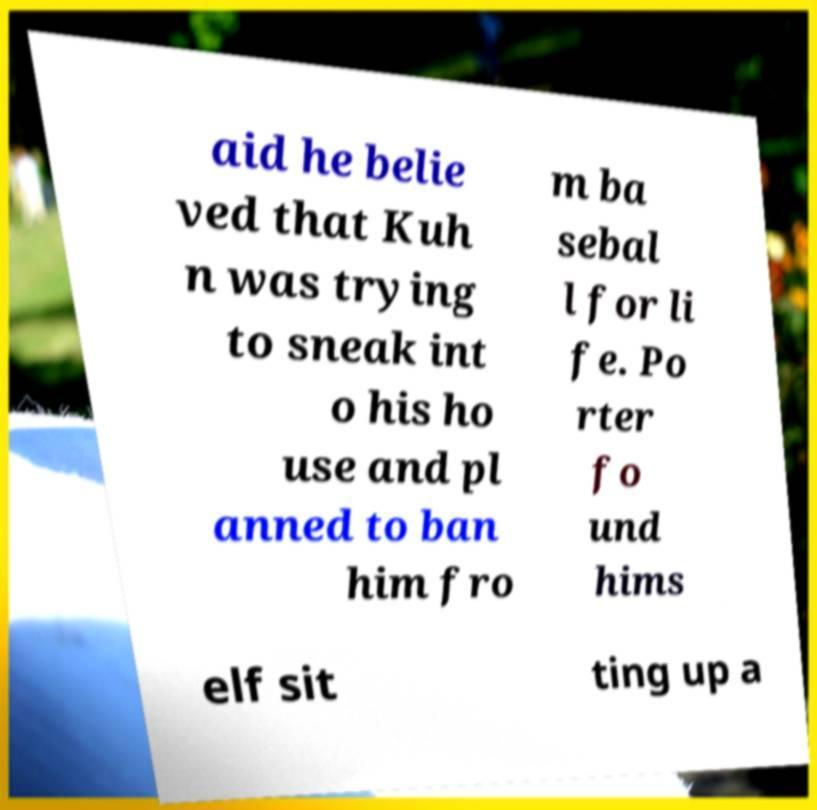There's text embedded in this image that I need extracted. Can you transcribe it verbatim? aid he belie ved that Kuh n was trying to sneak int o his ho use and pl anned to ban him fro m ba sebal l for li fe. Po rter fo und hims elf sit ting up a 